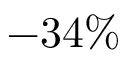<formula> <loc_0><loc_0><loc_500><loc_500>- 3 4 \%</formula> 